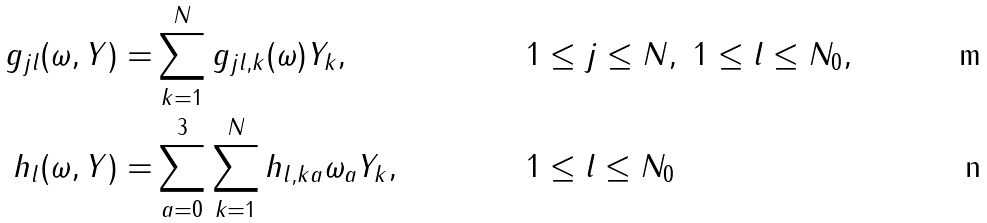Convert formula to latex. <formula><loc_0><loc_0><loc_500><loc_500>g _ { j l } ( \omega , Y ) = & \sum _ { k = 1 } ^ { N } g _ { j l , k } ( \omega ) Y _ { k } , & & 1 \leq j \leq N , \ 1 \leq l \leq N _ { 0 } , \\ h _ { l } ( \omega , Y ) = & \sum _ { a = 0 } ^ { 3 } \sum _ { k = 1 } ^ { N } h _ { l , k a } \omega _ { a } Y _ { k } , & & 1 \leq l \leq N _ { 0 }</formula> 